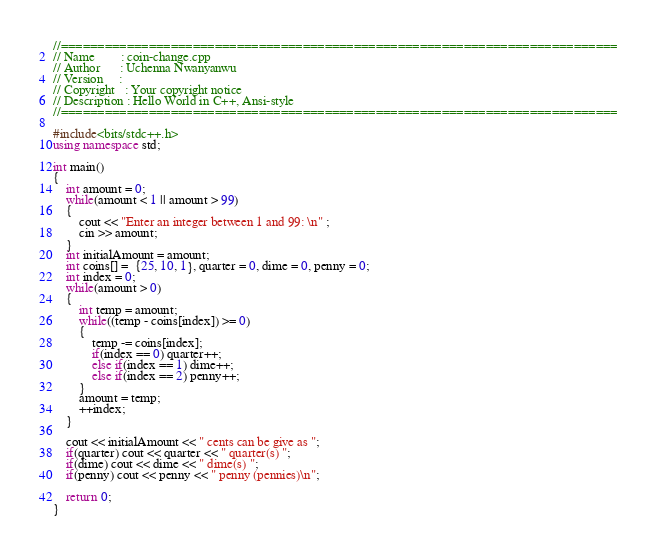Convert code to text. <code><loc_0><loc_0><loc_500><loc_500><_C++_>//============================================================================
// Name        : coin-change.cpp
// Author      : Uchenna Nwanyanwu
// Version     :
// Copyright   : Your copyright notice
// Description : Hello World in C++, Ansi-style
//============================================================================

#include<bits/stdc++.h>
using namespace std;

int main()
{
	int amount = 0;
	while(amount < 1 || amount > 99)
	{
		cout << "Enter an integer between 1 and 99: \n" ;
		cin >> amount;
	}
	int initialAmount = amount;
    int coins[] =  {25, 10, 1}, quarter = 0, dime = 0, penny = 0;
    int index = 0;
    while(amount > 0)
    {
    	int temp = amount;
    	while((temp - coins[index]) >= 0)
    	{
    		temp -= coins[index];
    		if(index == 0) quarter++;
    		else if(index == 1) dime++;
    		else if(index == 2) penny++;
    	}
    	amount = temp;
    	++index;
    }

    cout << initialAmount << " cents can be give as ";
    if(quarter) cout << quarter << " quarter(s) ";
    if(dime) cout << dime << " dime(s) ";
    if(penny) cout << penny << " penny (pennies)\n";

    return 0;
}
</code> 